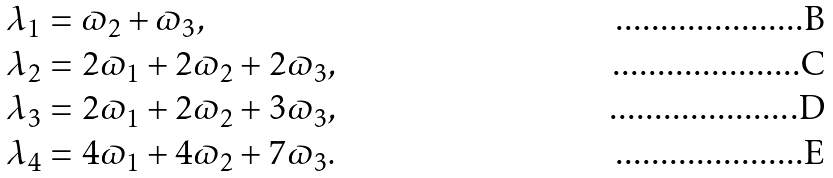Convert formula to latex. <formula><loc_0><loc_0><loc_500><loc_500>\lambda _ { 1 } & = \varpi _ { 2 } + \varpi _ { 3 } , \\ \lambda _ { 2 } & = 2 \varpi _ { 1 } + 2 \varpi _ { 2 } + 2 \varpi _ { 3 } , \\ \lambda _ { 3 } & = 2 \varpi _ { 1 } + 2 \varpi _ { 2 } + 3 \varpi _ { 3 } , \\ \lambda _ { 4 } & = 4 \varpi _ { 1 } + 4 \varpi _ { 2 } + 7 \varpi _ { 3 } .</formula> 